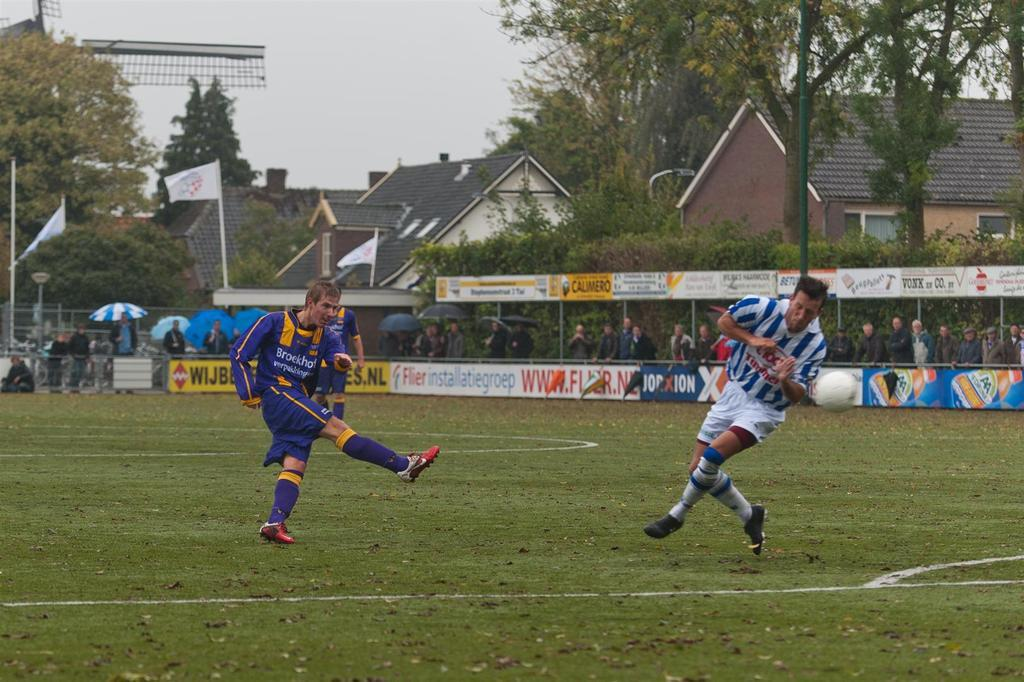<image>
Write a terse but informative summary of the picture. A yellow sign that starts with WIJB lines the edge of a soccer field. 